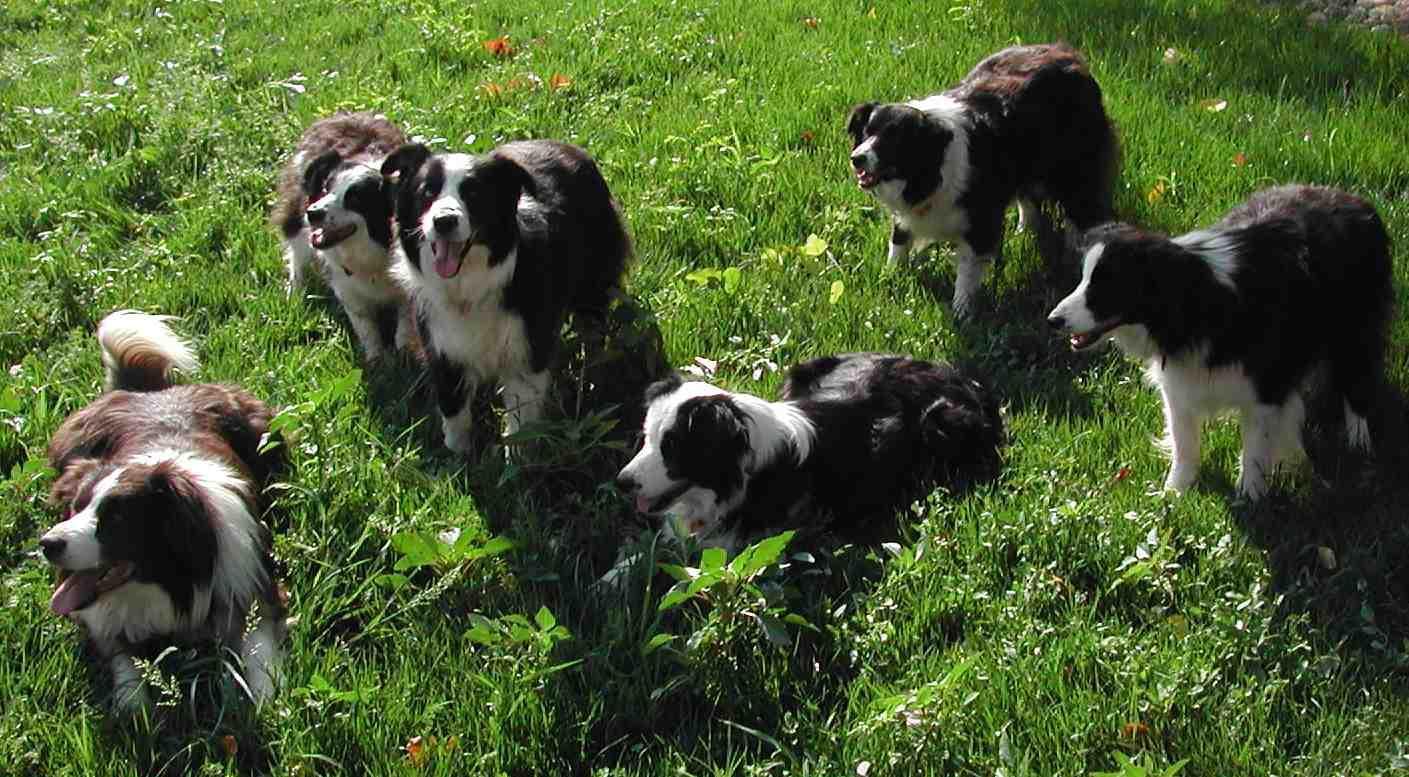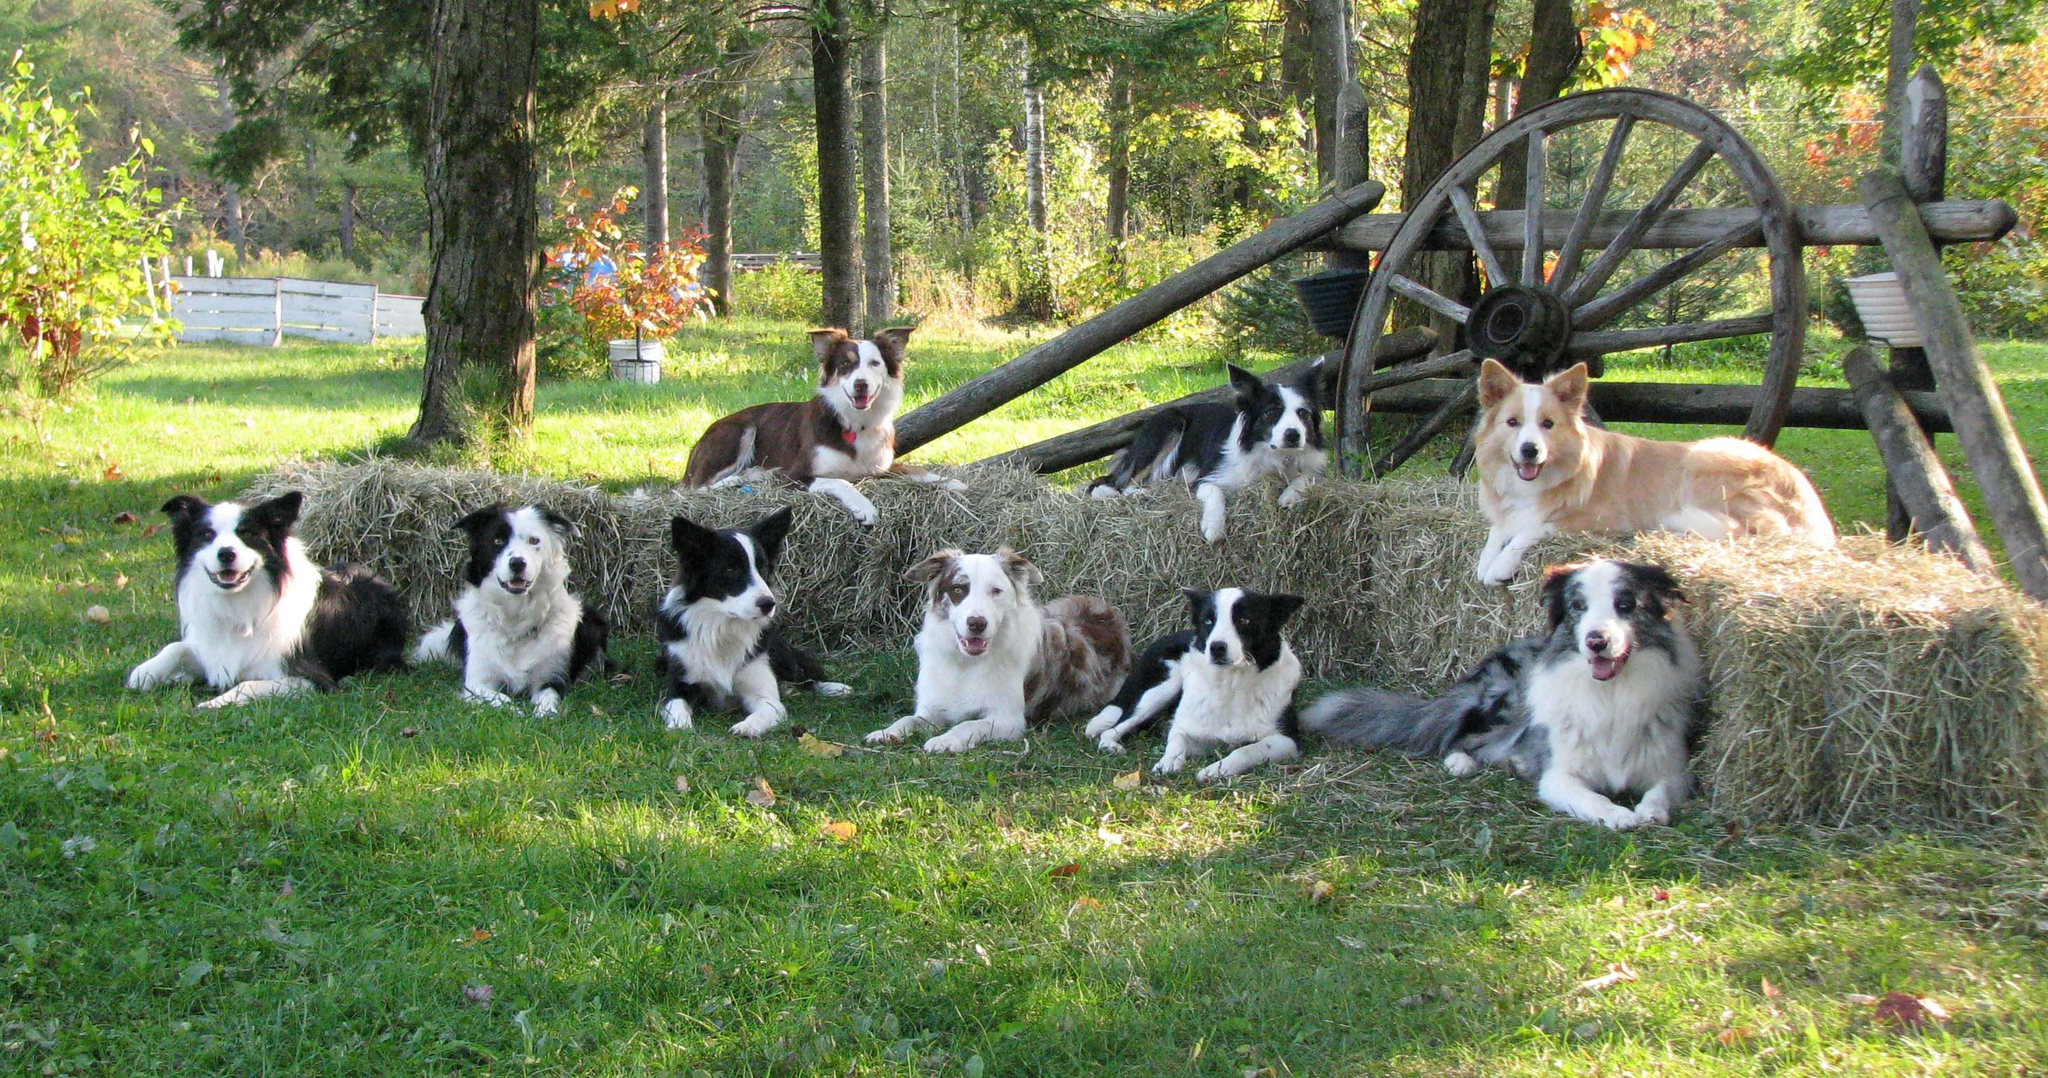The first image is the image on the left, the second image is the image on the right. Examine the images to the left and right. Is the description "There are four dogs in the left image." accurate? Answer yes or no. No. The first image is the image on the left, the second image is the image on the right. Examine the images to the left and right. Is the description "A horizontal row of reclining dogs poses in front of some type of rail structure." accurate? Answer yes or no. Yes. 